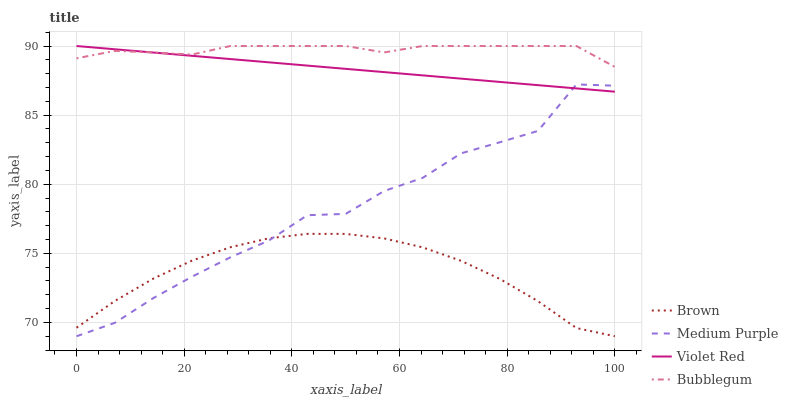Does Violet Red have the minimum area under the curve?
Answer yes or no. No. Does Violet Red have the maximum area under the curve?
Answer yes or no. No. Is Brown the smoothest?
Answer yes or no. No. Is Brown the roughest?
Answer yes or no. No. Does Violet Red have the lowest value?
Answer yes or no. No. Does Brown have the highest value?
Answer yes or no. No. Is Brown less than Bubblegum?
Answer yes or no. Yes. Is Bubblegum greater than Brown?
Answer yes or no. Yes. Does Brown intersect Bubblegum?
Answer yes or no. No. 